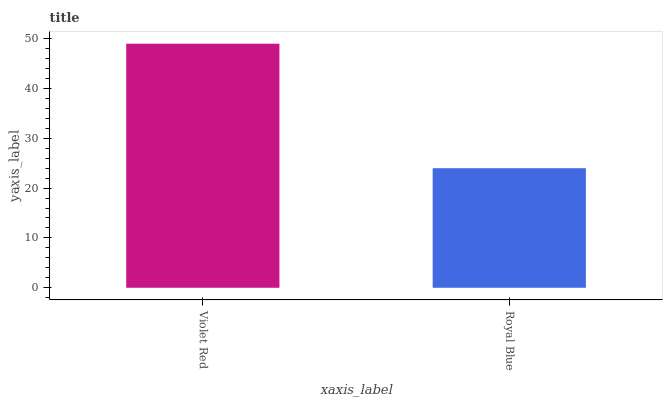Is Royal Blue the minimum?
Answer yes or no. Yes. Is Violet Red the maximum?
Answer yes or no. Yes. Is Royal Blue the maximum?
Answer yes or no. No. Is Violet Red greater than Royal Blue?
Answer yes or no. Yes. Is Royal Blue less than Violet Red?
Answer yes or no. Yes. Is Royal Blue greater than Violet Red?
Answer yes or no. No. Is Violet Red less than Royal Blue?
Answer yes or no. No. Is Violet Red the high median?
Answer yes or no. Yes. Is Royal Blue the low median?
Answer yes or no. Yes. Is Royal Blue the high median?
Answer yes or no. No. Is Violet Red the low median?
Answer yes or no. No. 